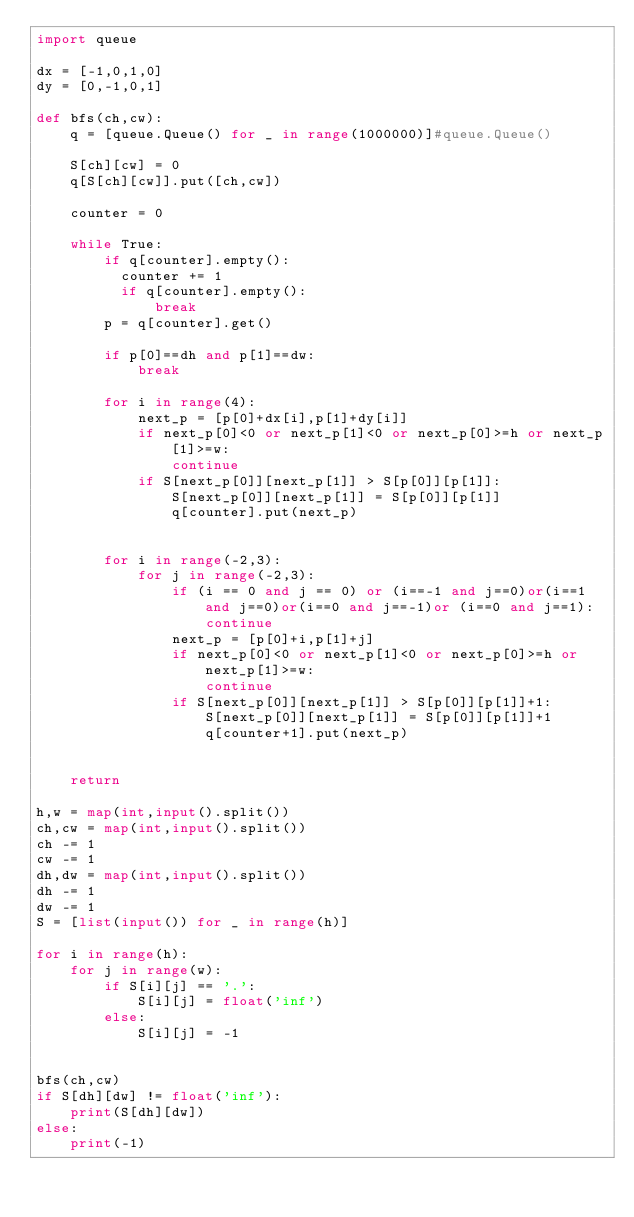Convert code to text. <code><loc_0><loc_0><loc_500><loc_500><_Python_>import queue
 
dx = [-1,0,1,0]
dy = [0,-1,0,1]
 
def bfs(ch,cw):
    q = [queue.Queue() for _ in range(1000000)]#queue.Queue()
    
    S[ch][cw] = 0
    q[S[ch][cw]].put([ch,cw])
    
    counter = 0
    
    while True:
        if q[counter].empty():
          counter += 1
          if q[counter].empty():
              break
        p = q[counter].get()
        
        if p[0]==dh and p[1]==dw:
            break
        
        for i in range(4):
            next_p = [p[0]+dx[i],p[1]+dy[i]]
            if next_p[0]<0 or next_p[1]<0 or next_p[0]>=h or next_p[1]>=w:
                continue
            if S[next_p[0]][next_p[1]] > S[p[0]][p[1]]:
                S[next_p[0]][next_p[1]] = S[p[0]][p[1]]
                q[counter].put(next_p)
                
                
        for i in range(-2,3):
            for j in range(-2,3):
                if (i == 0 and j == 0) or (i==-1 and j==0)or(i==1 and j==0)or(i==0 and j==-1)or (i==0 and j==1):
                    continue
                next_p = [p[0]+i,p[1]+j]
                if next_p[0]<0 or next_p[1]<0 or next_p[0]>=h or next_p[1]>=w:
                    continue
                if S[next_p[0]][next_p[1]] > S[p[0]][p[1]]+1:
                    S[next_p[0]][next_p[1]] = S[p[0]][p[1]]+1
                    q[counter+1].put(next_p)
                    
            
    return 
        
h,w = map(int,input().split())
ch,cw = map(int,input().split())
ch -= 1
cw -= 1
dh,dw = map(int,input().split())
dh -= 1
dw -= 1
S = [list(input()) for _ in range(h)]
 
for i in range(h):
    for j in range(w):
        if S[i][j] == '.':
            S[i][j] = float('inf')
        else:
            S[i][j] = -1
 
 
bfs(ch,cw)
if S[dh][dw] != float('inf'):
    print(S[dh][dw])
else:
    print(-1)</code> 